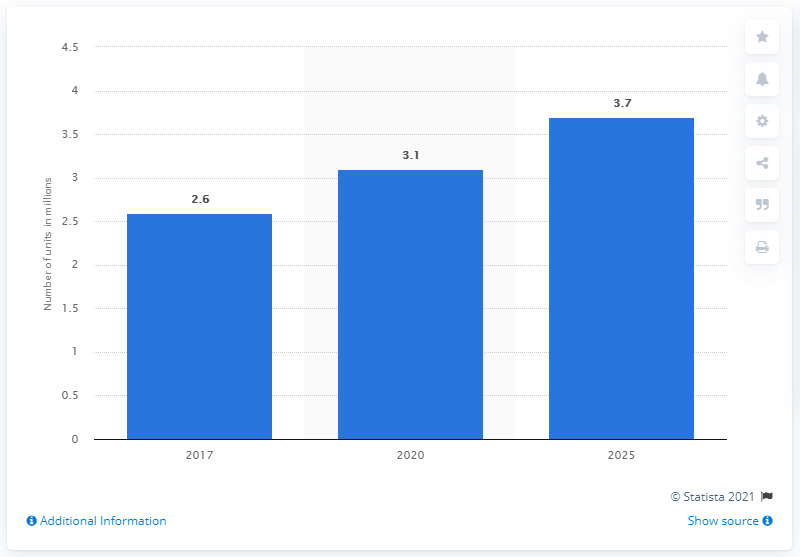Outline some significant characteristics in this image. In 2017, there were approximately 2.6 billion IoT transport units in use. 